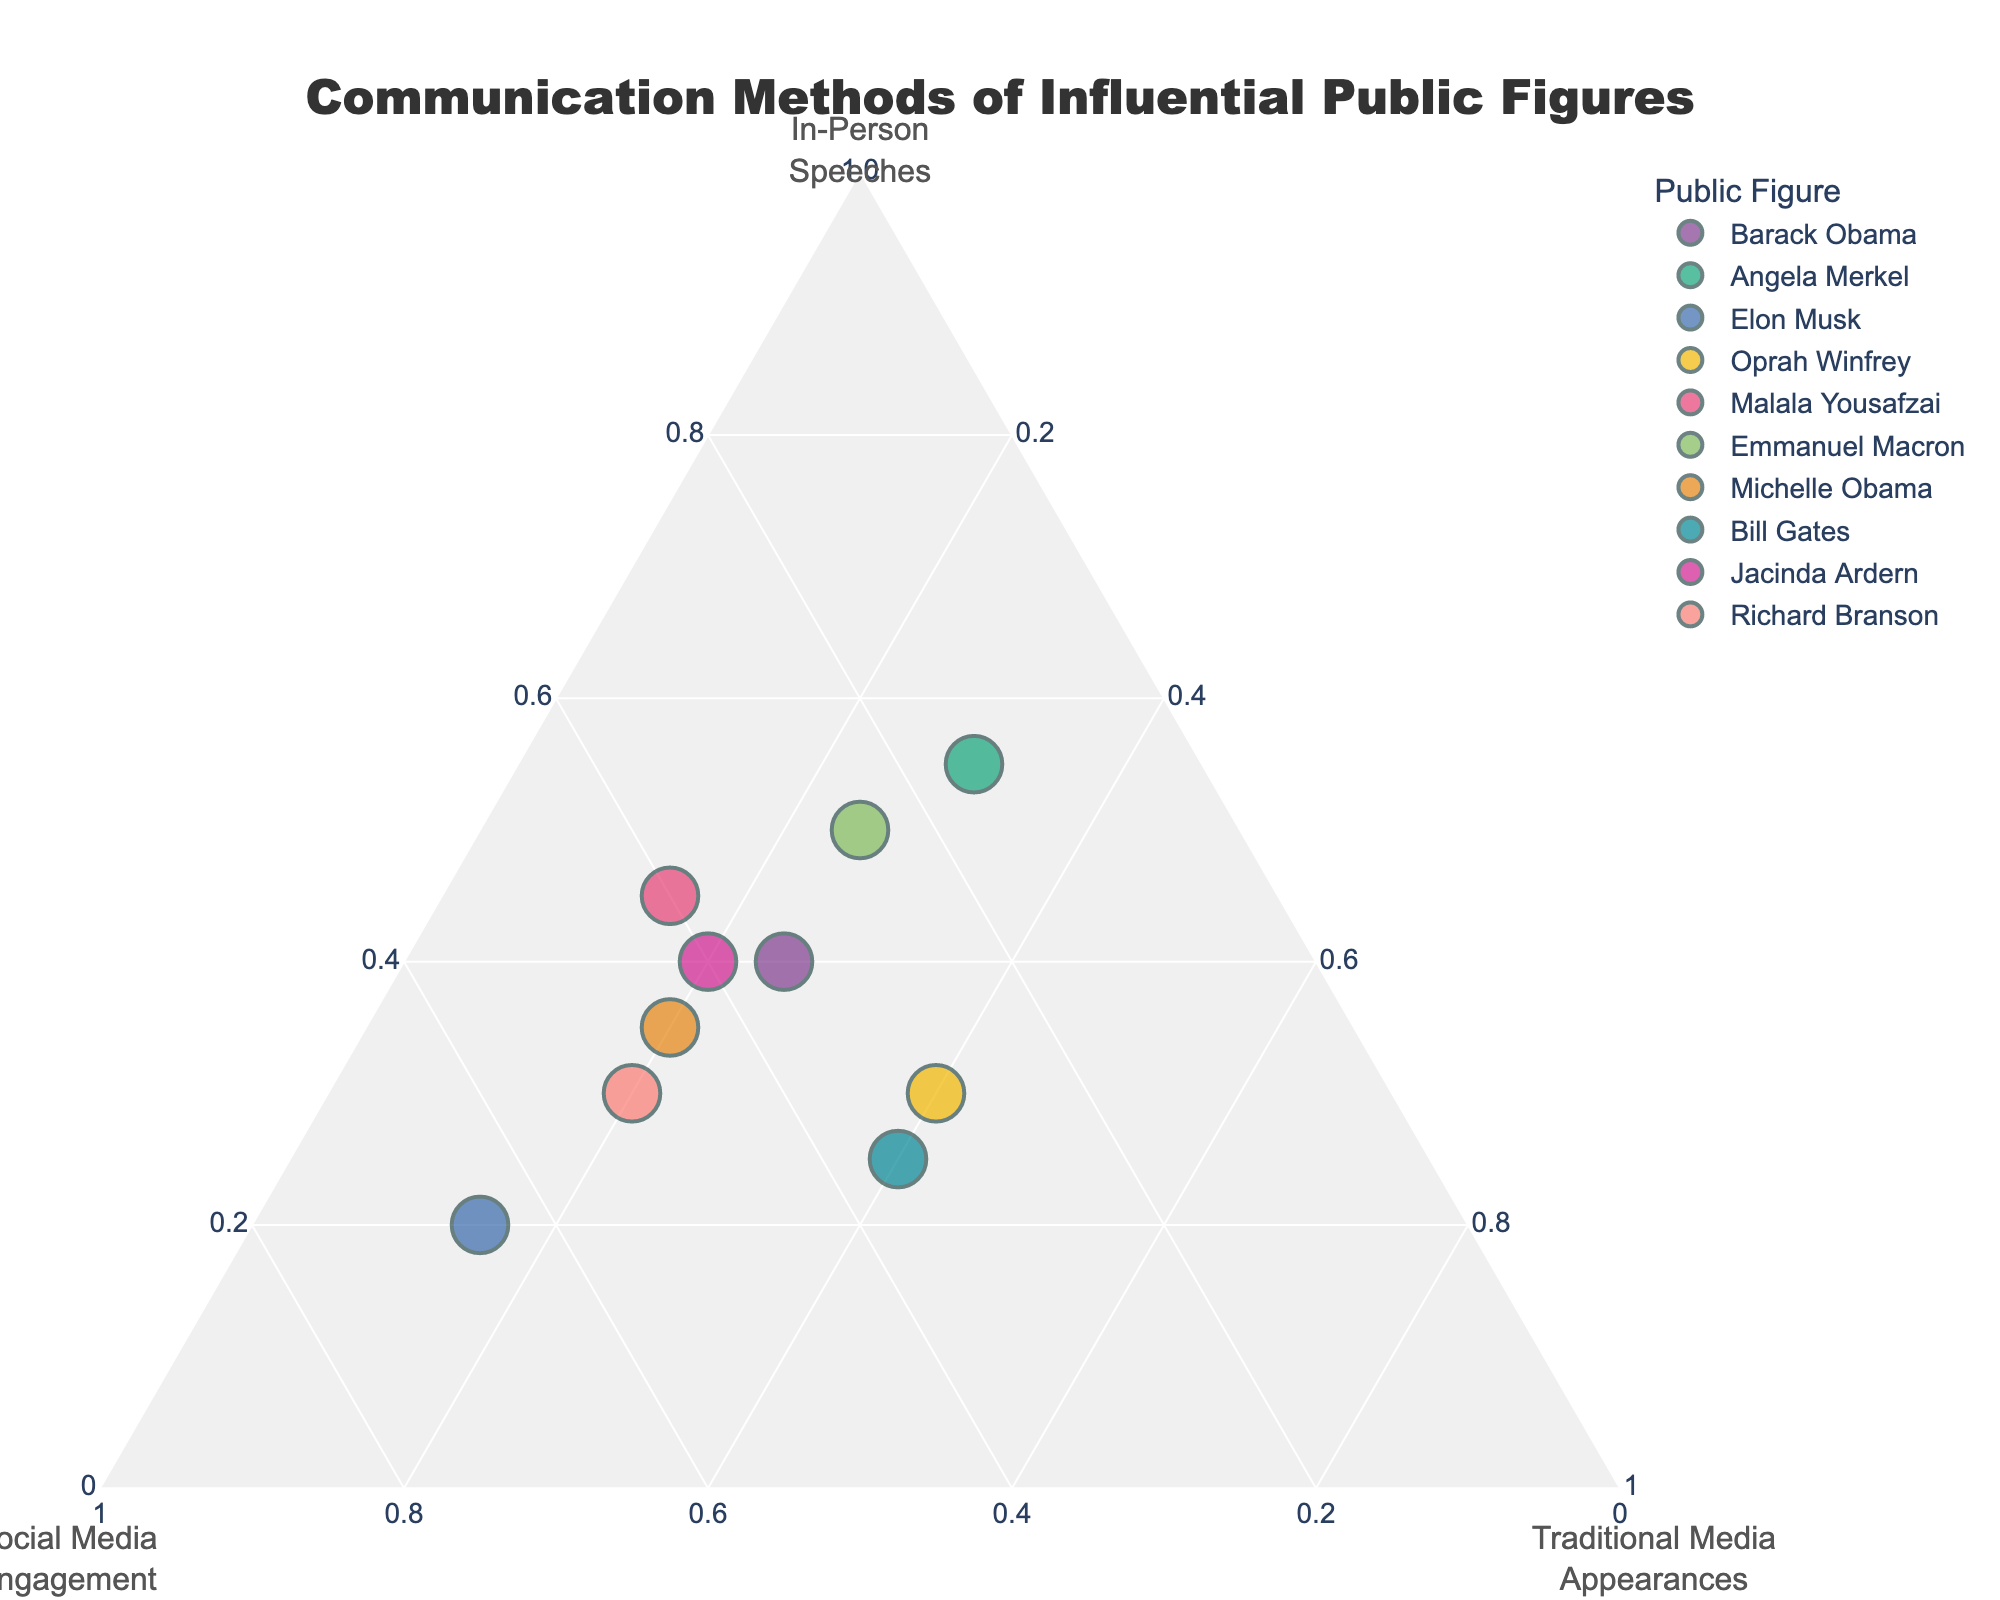What's the title of the figure? The title is written at the top of the figure in a larger, bold font.
Answer: Communication Methods of Influential Public Figures Which axis represents "Traditional Media Appearances"? Look for the axis title labeled "Traditional Media<br>Appearances," which will be placed correspondingly.
Answer: The bottom axis Who has the highest proportion of "Social Media Engagement"? Find the data point closest to the "Social Media Engagement" vertex, which represents a higher proportion in that category.
Answer: Elon Musk Who has an equal proportion of "In-Person Speeches" and "Social Media Engagement"? Identify the data points equidistant between "In-Person Speeches" and "Social Media Engagement" axes.
Answer: Oprah Winfrey What is the proportion of "Traditional Media Appearances" for Barack Obama? Spot Barack Obama's data point and trace its position relative to the "Traditional Media Appearances" axis.
Answer: 0.25 How many public figures have at least 0.4 for "In-Person Speeches"? Count the number of data points near the "In-Person Speeches" vertex that satisfies this criterion.
Answer: 4 (Angela Merkel, Emmanuel Macron, Malala Yousafzai, Jacinda Ardern) Who utilizes social media more than both traditional media and in-person speeches? Check for data points closer to the "Social Media Engagement" compared to the other two categories.
Answer: Elon Musk For Michelle Obama, which communication method does she use the most? Track the respective position of Michelle Obama's data point concerning the three vertexes.
Answer: Social Media Engagement What’s the difference in the proportion of in-person speeches between Jacinda Ardern and Richard Branson? Deduct Richard Branson's proportion from Jacinda Ardern’s value in the in-person speeches data.
Answer: 0.1 Which figures lie at the center of the ternary plot indicating almost equal use of all methods? Find the data points placed at the center, indicating similar use across all three categories.
Answer: None 